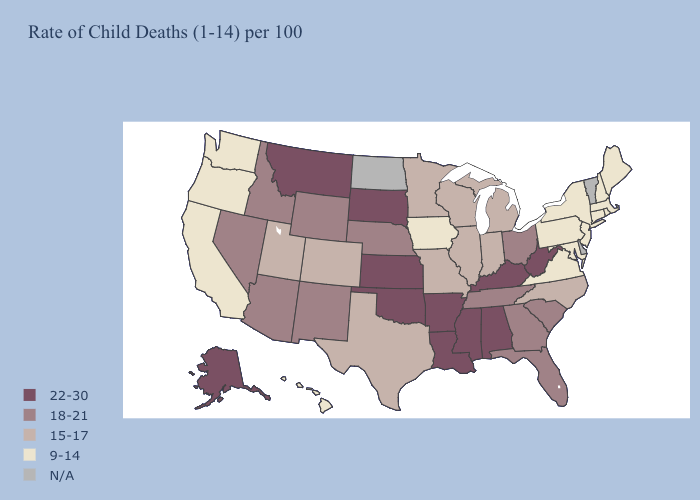Name the states that have a value in the range 22-30?
Write a very short answer. Alabama, Alaska, Arkansas, Kansas, Kentucky, Louisiana, Mississippi, Montana, Oklahoma, South Dakota, West Virginia. Among the states that border South Dakota , which have the highest value?
Be succinct. Montana. What is the highest value in states that border South Carolina?
Short answer required. 18-21. What is the highest value in the South ?
Concise answer only. 22-30. Name the states that have a value in the range 9-14?
Concise answer only. California, Connecticut, Hawaii, Iowa, Maine, Maryland, Massachusetts, New Hampshire, New Jersey, New York, Oregon, Pennsylvania, Rhode Island, Virginia, Washington. What is the value of New Hampshire?
Give a very brief answer. 9-14. Among the states that border Colorado , which have the lowest value?
Give a very brief answer. Utah. What is the lowest value in the MidWest?
Give a very brief answer. 9-14. Name the states that have a value in the range N/A?
Keep it brief. Delaware, North Dakota, Vermont. What is the highest value in the West ?
Answer briefly. 22-30. What is the highest value in the USA?
Quick response, please. 22-30. Which states hav the highest value in the Northeast?
Short answer required. Connecticut, Maine, Massachusetts, New Hampshire, New Jersey, New York, Pennsylvania, Rhode Island. Name the states that have a value in the range 15-17?
Short answer required. Colorado, Illinois, Indiana, Michigan, Minnesota, Missouri, North Carolina, Texas, Utah, Wisconsin. What is the lowest value in the USA?
Write a very short answer. 9-14. What is the lowest value in the MidWest?
Be succinct. 9-14. 